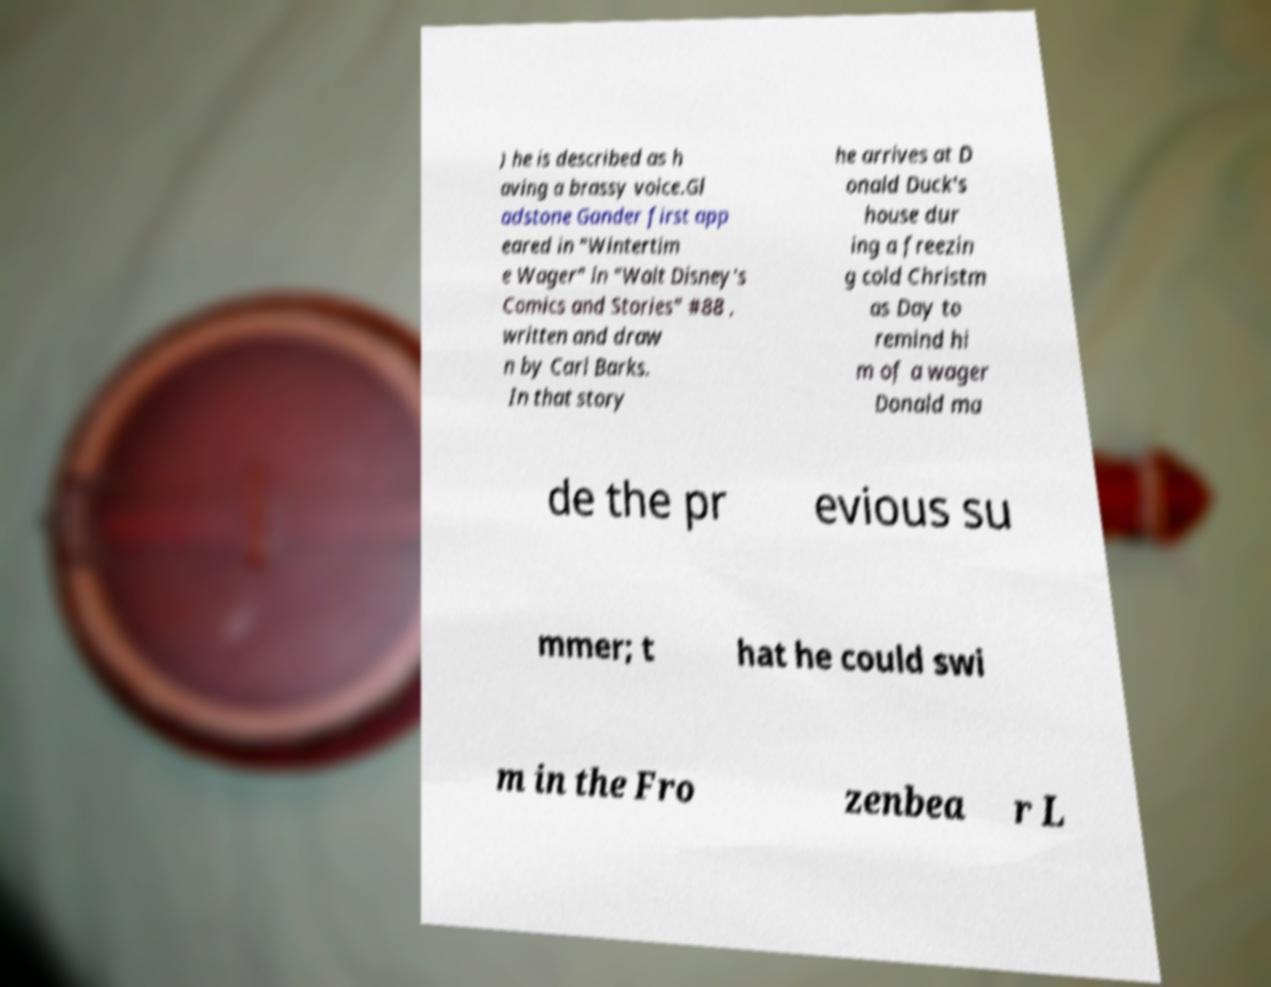What messages or text are displayed in this image? I need them in a readable, typed format. ) he is described as h aving a brassy voice.Gl adstone Gander first app eared in "Wintertim e Wager" in "Walt Disney's Comics and Stories" #88 , written and draw n by Carl Barks. In that story he arrives at D onald Duck's house dur ing a freezin g cold Christm as Day to remind hi m of a wager Donald ma de the pr evious su mmer; t hat he could swi m in the Fro zenbea r L 